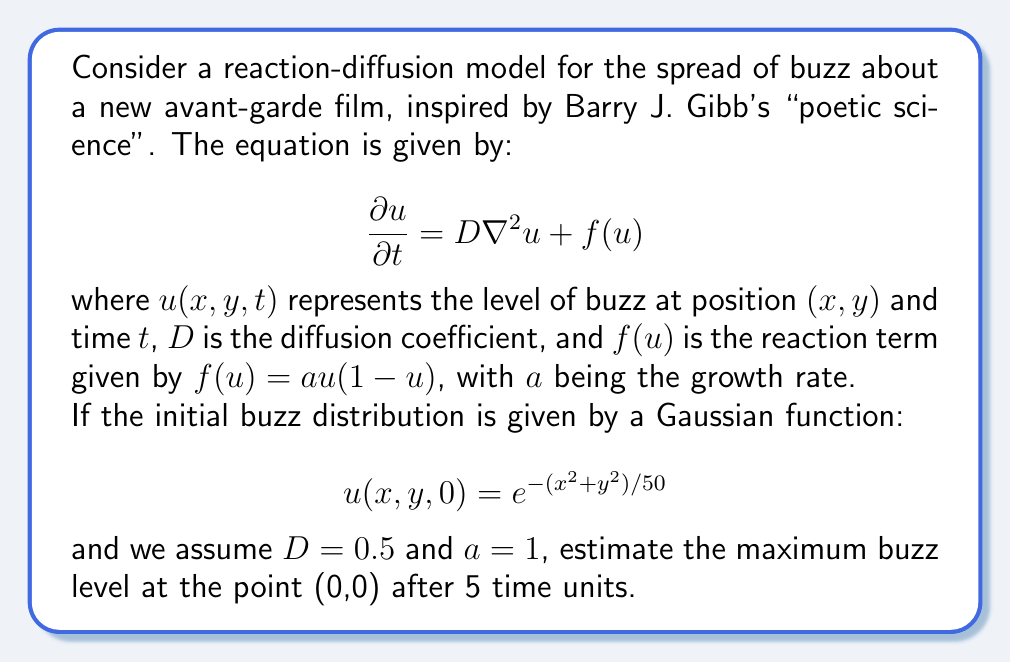Provide a solution to this math problem. To solve this problem, we need to consider the reaction-diffusion equation and its initial conditions. While an exact analytical solution is complex, we can use a simplified approach to estimate the maximum buzz level.

1) First, let's consider the reaction term separately. Without diffusion, the equation would be:

   $$\frac{du}{dt} = au(1-u)$$

   This is a logistic growth model with a maximum value of 1.

2) The initial condition at (0,0) is:

   $$u(0,0,0) = e^{-(0^2+0^2)/50} = 1$$

3) The diffusion term $D\nabla^2u$ tends to spread out the buzz, reducing the maximum value. However, in this case, the initial condition is already at the maximum of the Gaussian, so diffusion will primarily act to reduce the peak value.

4) Given that the initial value is at the maximum of both the spatial distribution and the logistic growth model, we can expect the value at (0,0) to decrease slightly over time due to diffusion.

5) To estimate the decrease, we can use the fact that for a Gaussian initial condition, the peak value in a pure diffusion equation (without reaction) would decrease as:

   $$u(0,0,t) = \frac{1}{\sqrt{1+4Dt/\sigma^2}}$$

   where $\sigma^2 = 25$ in our case (from the initial condition).

6) Combining this with the fact that the reaction term will try to push the value back up to 1, we can estimate the value after 5 time units as:

   $$u(0,0,5) \approx 1 - \frac{1}{2}\left(1 - \frac{1}{\sqrt{1+4D\cdot5/25}}\right)$$

7) Plugging in $D = 0.5$:

   $$u(0,0,5) \approx 1 - \frac{1}{2}\left(1 - \frac{1}{\sqrt{1+0.4}}\right) = 1 - \frac{1}{2}\left(1 - \frac{1}{\sqrt{1.4}}\right) \approx 0.916$$

This estimation takes into account both the spreading effect of diffusion and the growth effect of the reaction term.
Answer: The estimated maximum buzz level at the point (0,0) after 5 time units is approximately 0.916. 